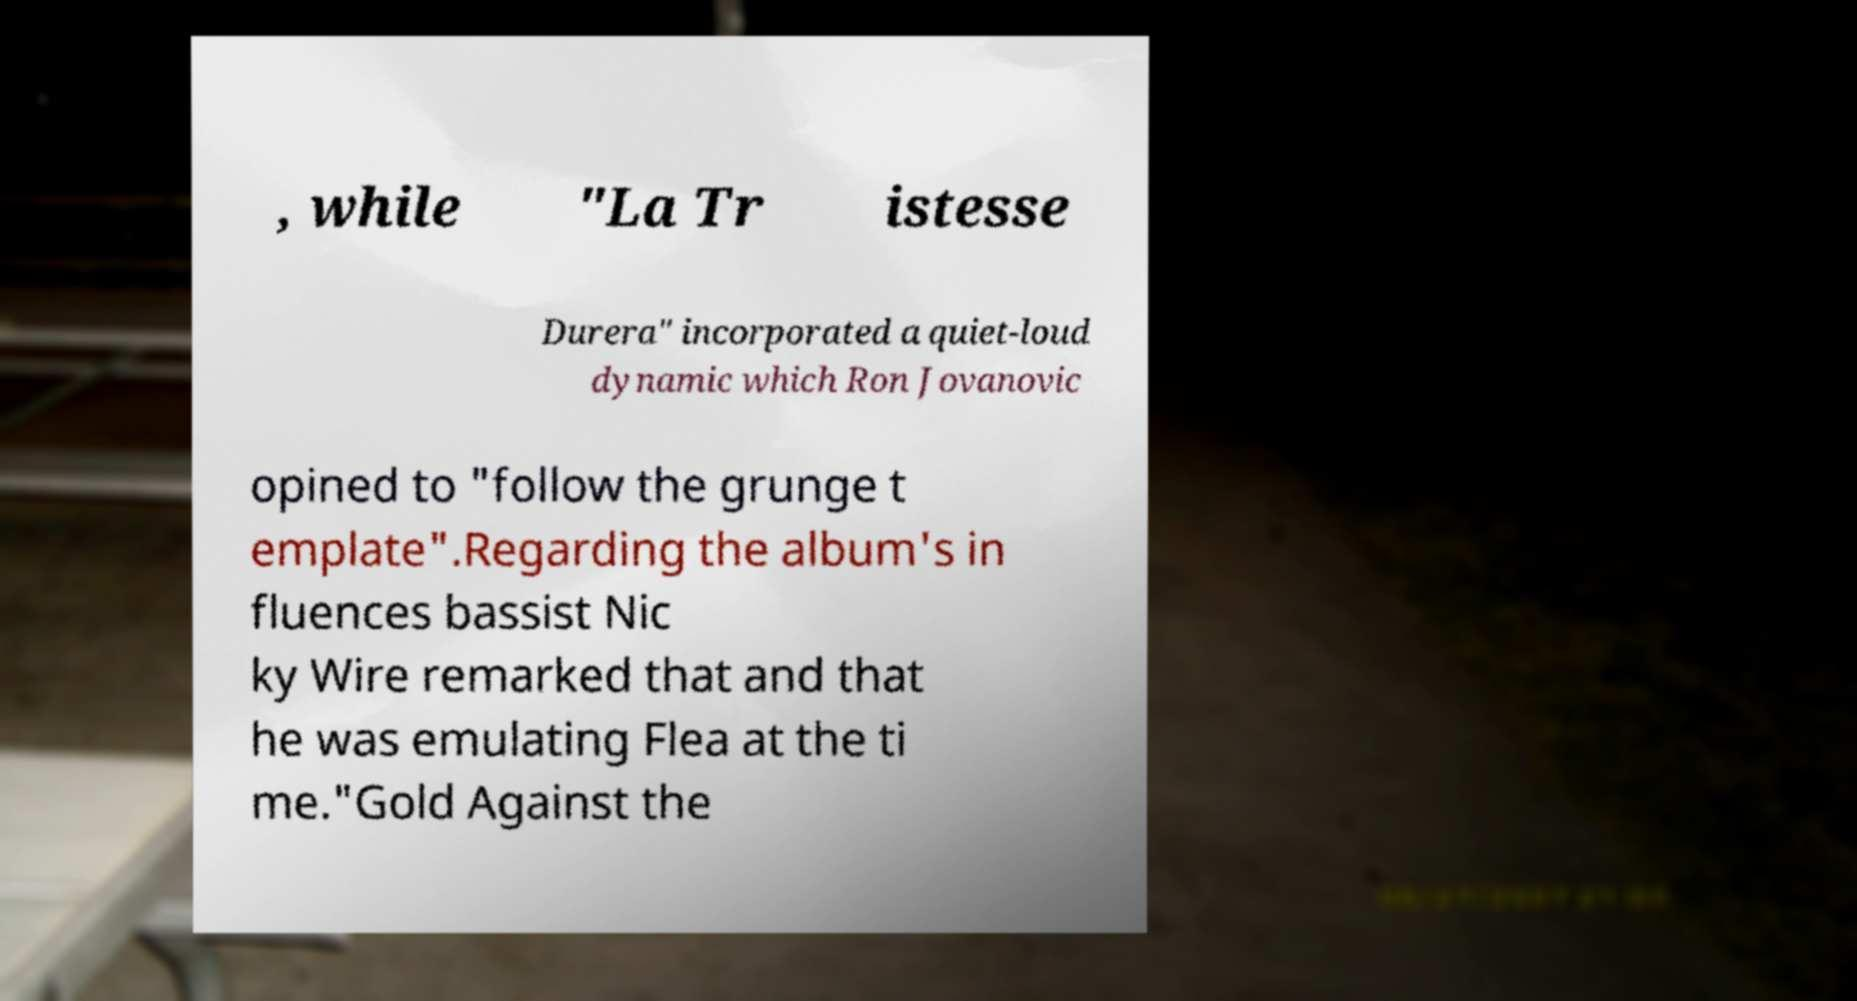Could you assist in decoding the text presented in this image and type it out clearly? , while "La Tr istesse Durera" incorporated a quiet-loud dynamic which Ron Jovanovic opined to "follow the grunge t emplate".Regarding the album's in fluences bassist Nic ky Wire remarked that and that he was emulating Flea at the ti me."Gold Against the 